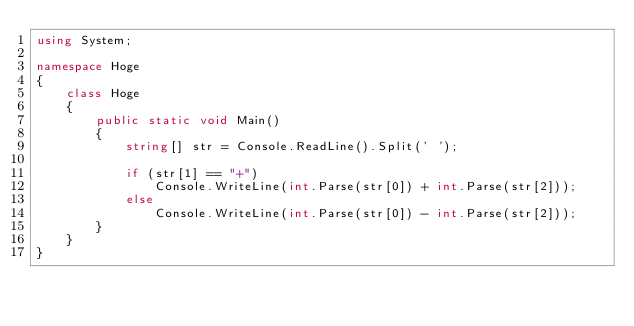Convert code to text. <code><loc_0><loc_0><loc_500><loc_500><_C#_>using System;

namespace Hoge
{
    class Hoge
    {
        public static void Main()
        {
            string[] str = Console.ReadLine().Split(' ');

            if (str[1] == "+")
                Console.WriteLine(int.Parse(str[0]) + int.Parse(str[2]));
            else
                Console.WriteLine(int.Parse(str[0]) - int.Parse(str[2]));
        }
    }
}</code> 